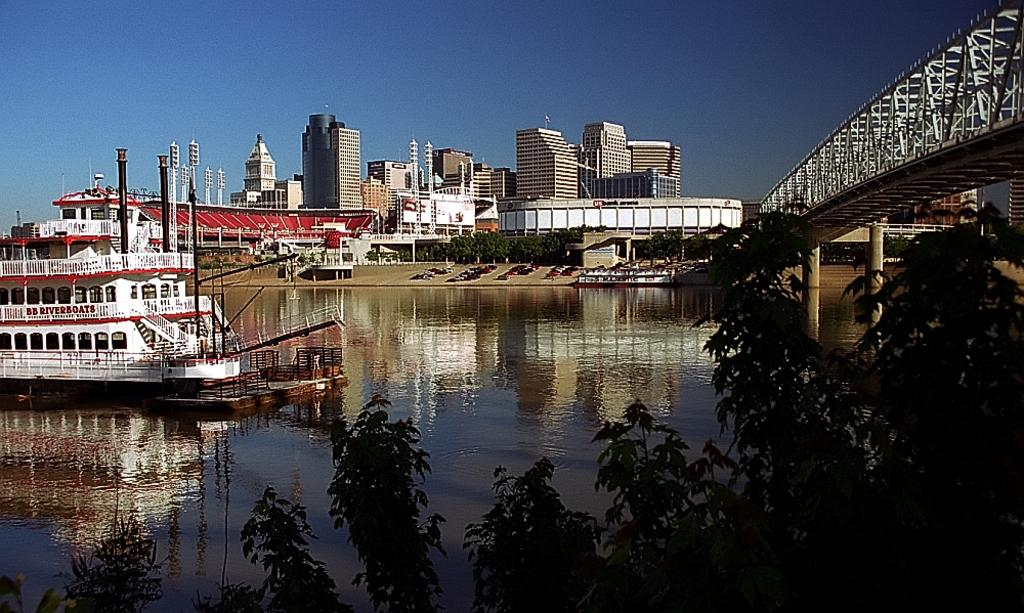What type of body of water is present in the image? There is a lake in the image. What is floating on the lake? There is a ship in the image. What type of vegetation is visible in the image? There are trees in the image. What connects the two sides of the lake? There is a bridge in the image. What structures are located near the lake? There are buildings near the lake. What is visible at the top of the image? The sky is visible at the top of the image. What type of alarm can be heard going off in the image? There is no alarm present in the image, and therefore no sound can be heard. What is the best way to cross the lake in the image? The image does not provide information on the best way to cross the lake, but the bridge is one option. 